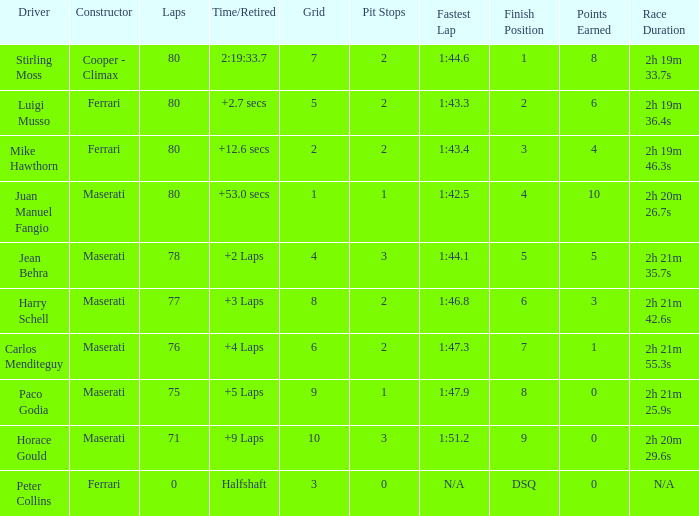What's the average Grid for a Maserati with less than 80 laps, and a Time/Retired of +2 laps? 4.0. 